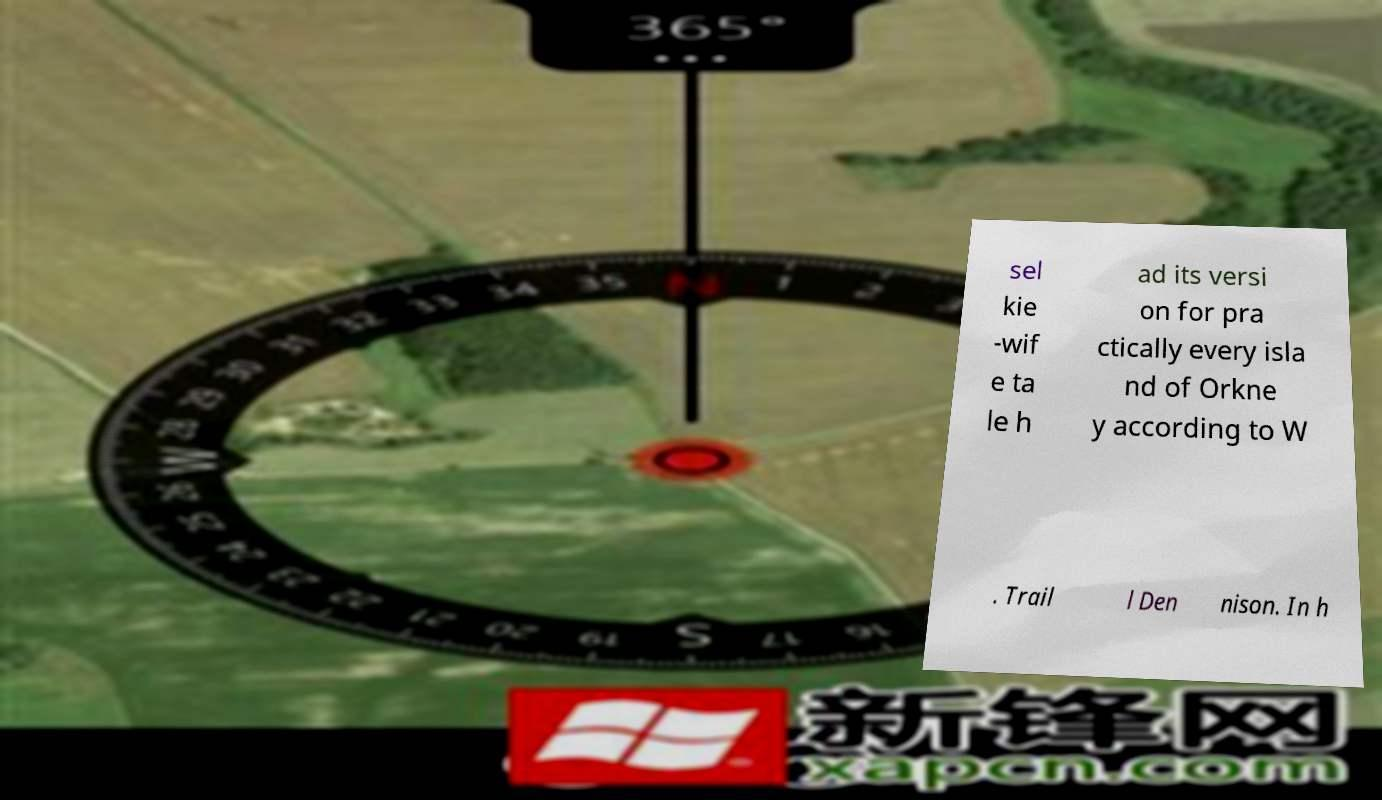There's text embedded in this image that I need extracted. Can you transcribe it verbatim? sel kie -wif e ta le h ad its versi on for pra ctically every isla nd of Orkne y according to W . Trail l Den nison. In h 